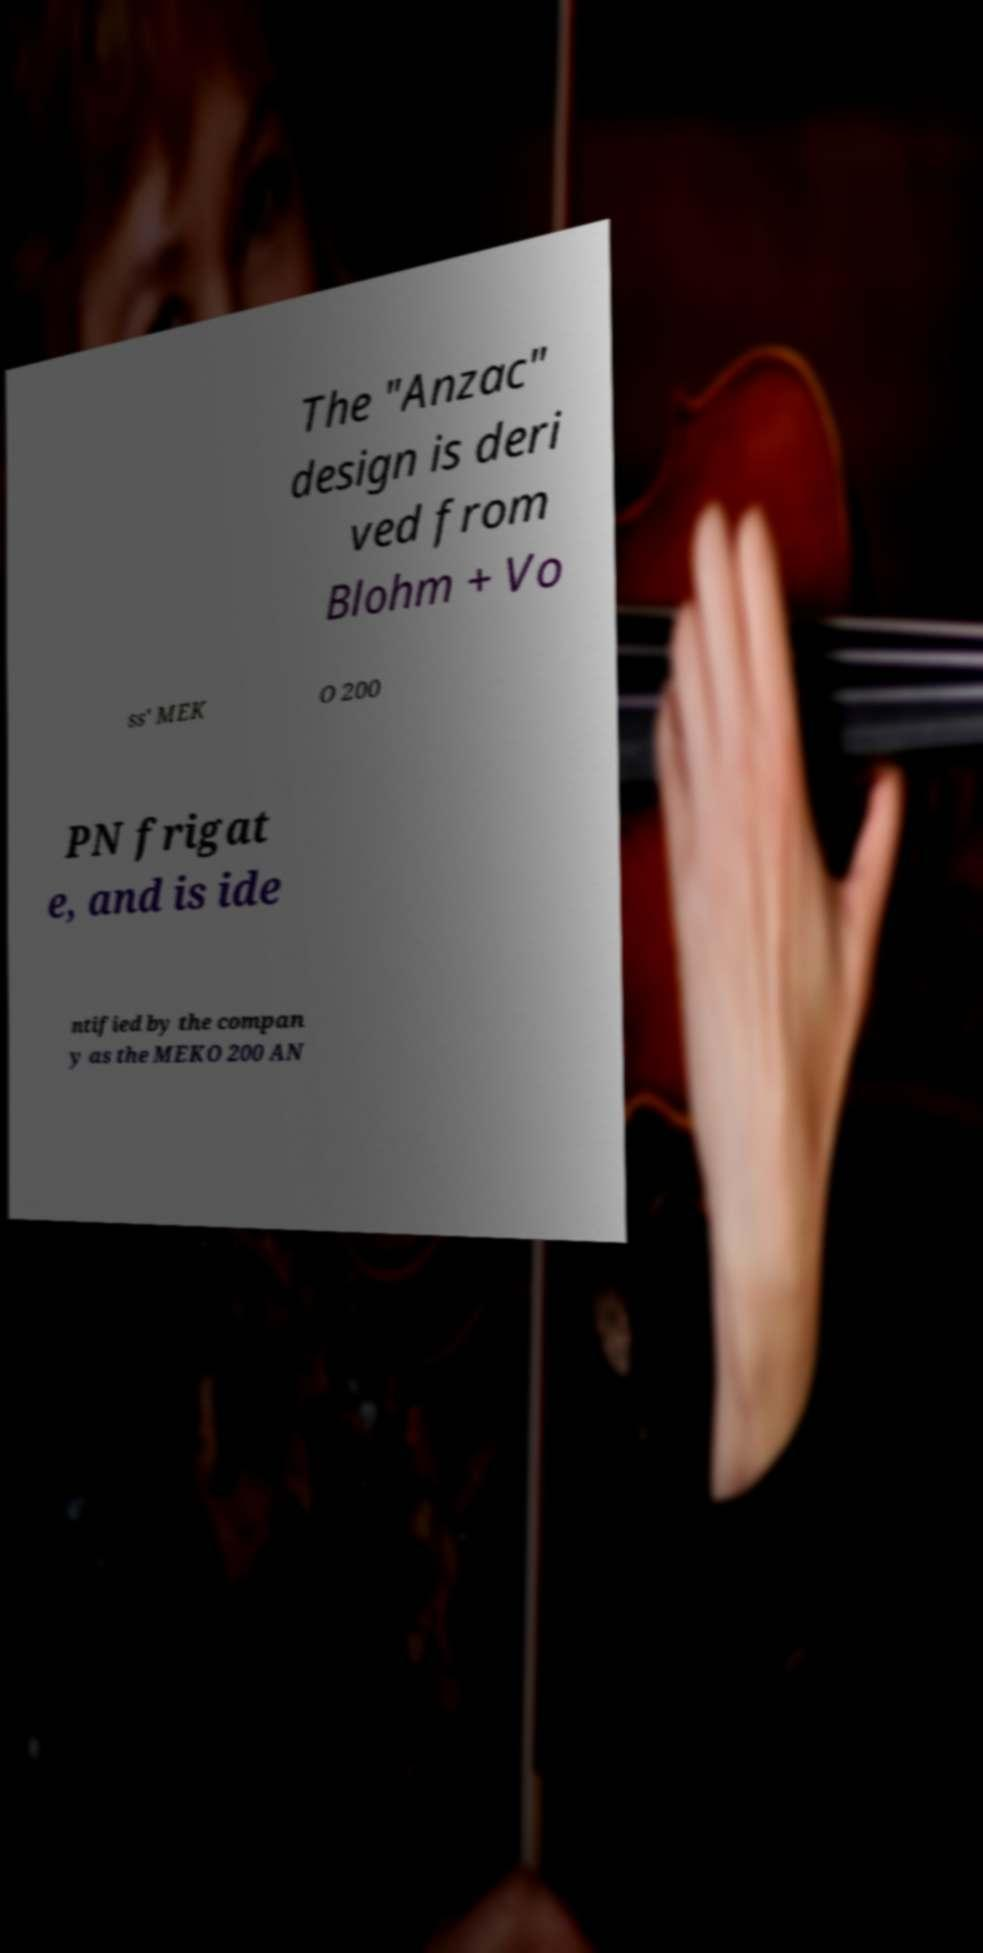Please identify and transcribe the text found in this image. The "Anzac" design is deri ved from Blohm + Vo ss' MEK O 200 PN frigat e, and is ide ntified by the compan y as the MEKO 200 AN 